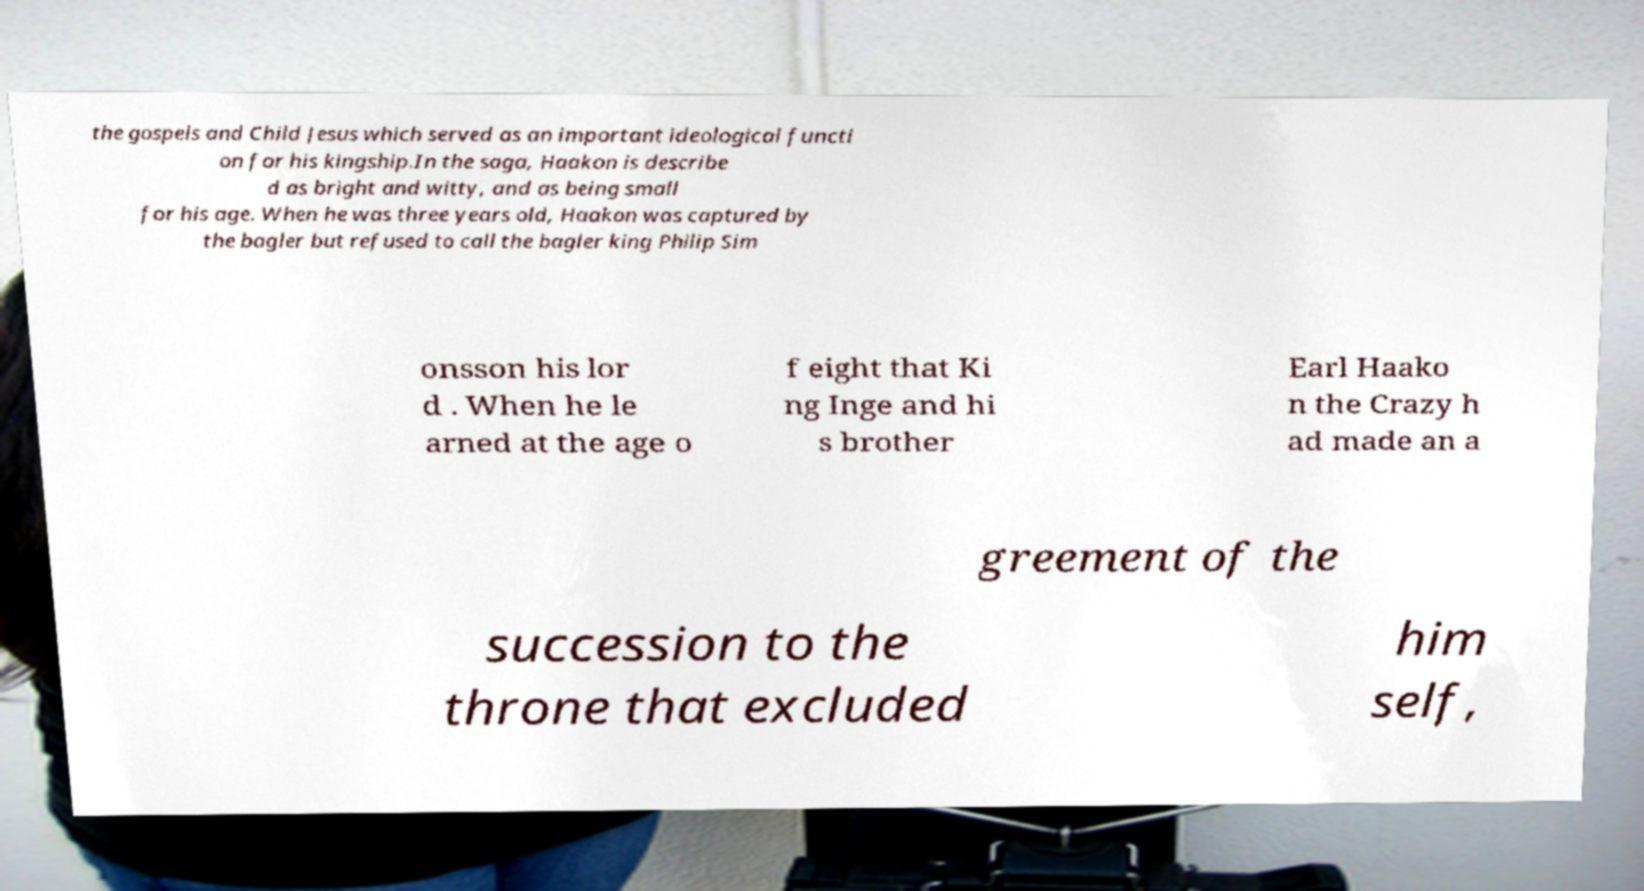For documentation purposes, I need the text within this image transcribed. Could you provide that? the gospels and Child Jesus which served as an important ideological functi on for his kingship.In the saga, Haakon is describe d as bright and witty, and as being small for his age. When he was three years old, Haakon was captured by the bagler but refused to call the bagler king Philip Sim onsson his lor d . When he le arned at the age o f eight that Ki ng Inge and hi s brother Earl Haako n the Crazy h ad made an a greement of the succession to the throne that excluded him self, 